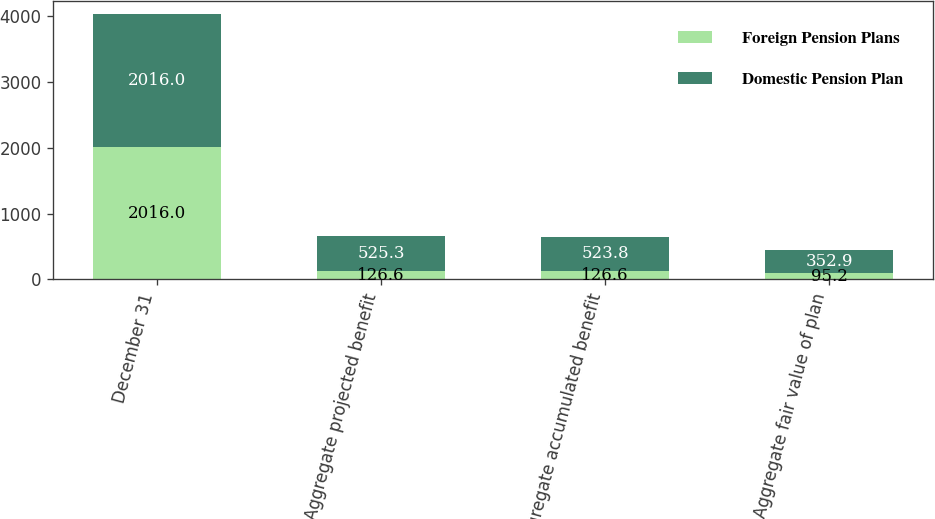Convert chart. <chart><loc_0><loc_0><loc_500><loc_500><stacked_bar_chart><ecel><fcel>December 31<fcel>Aggregate projected benefit<fcel>Aggregate accumulated benefit<fcel>Aggregate fair value of plan<nl><fcel>Foreign Pension Plans<fcel>2016<fcel>126.6<fcel>126.6<fcel>95.2<nl><fcel>Domestic Pension Plan<fcel>2016<fcel>525.3<fcel>523.8<fcel>352.9<nl></chart> 